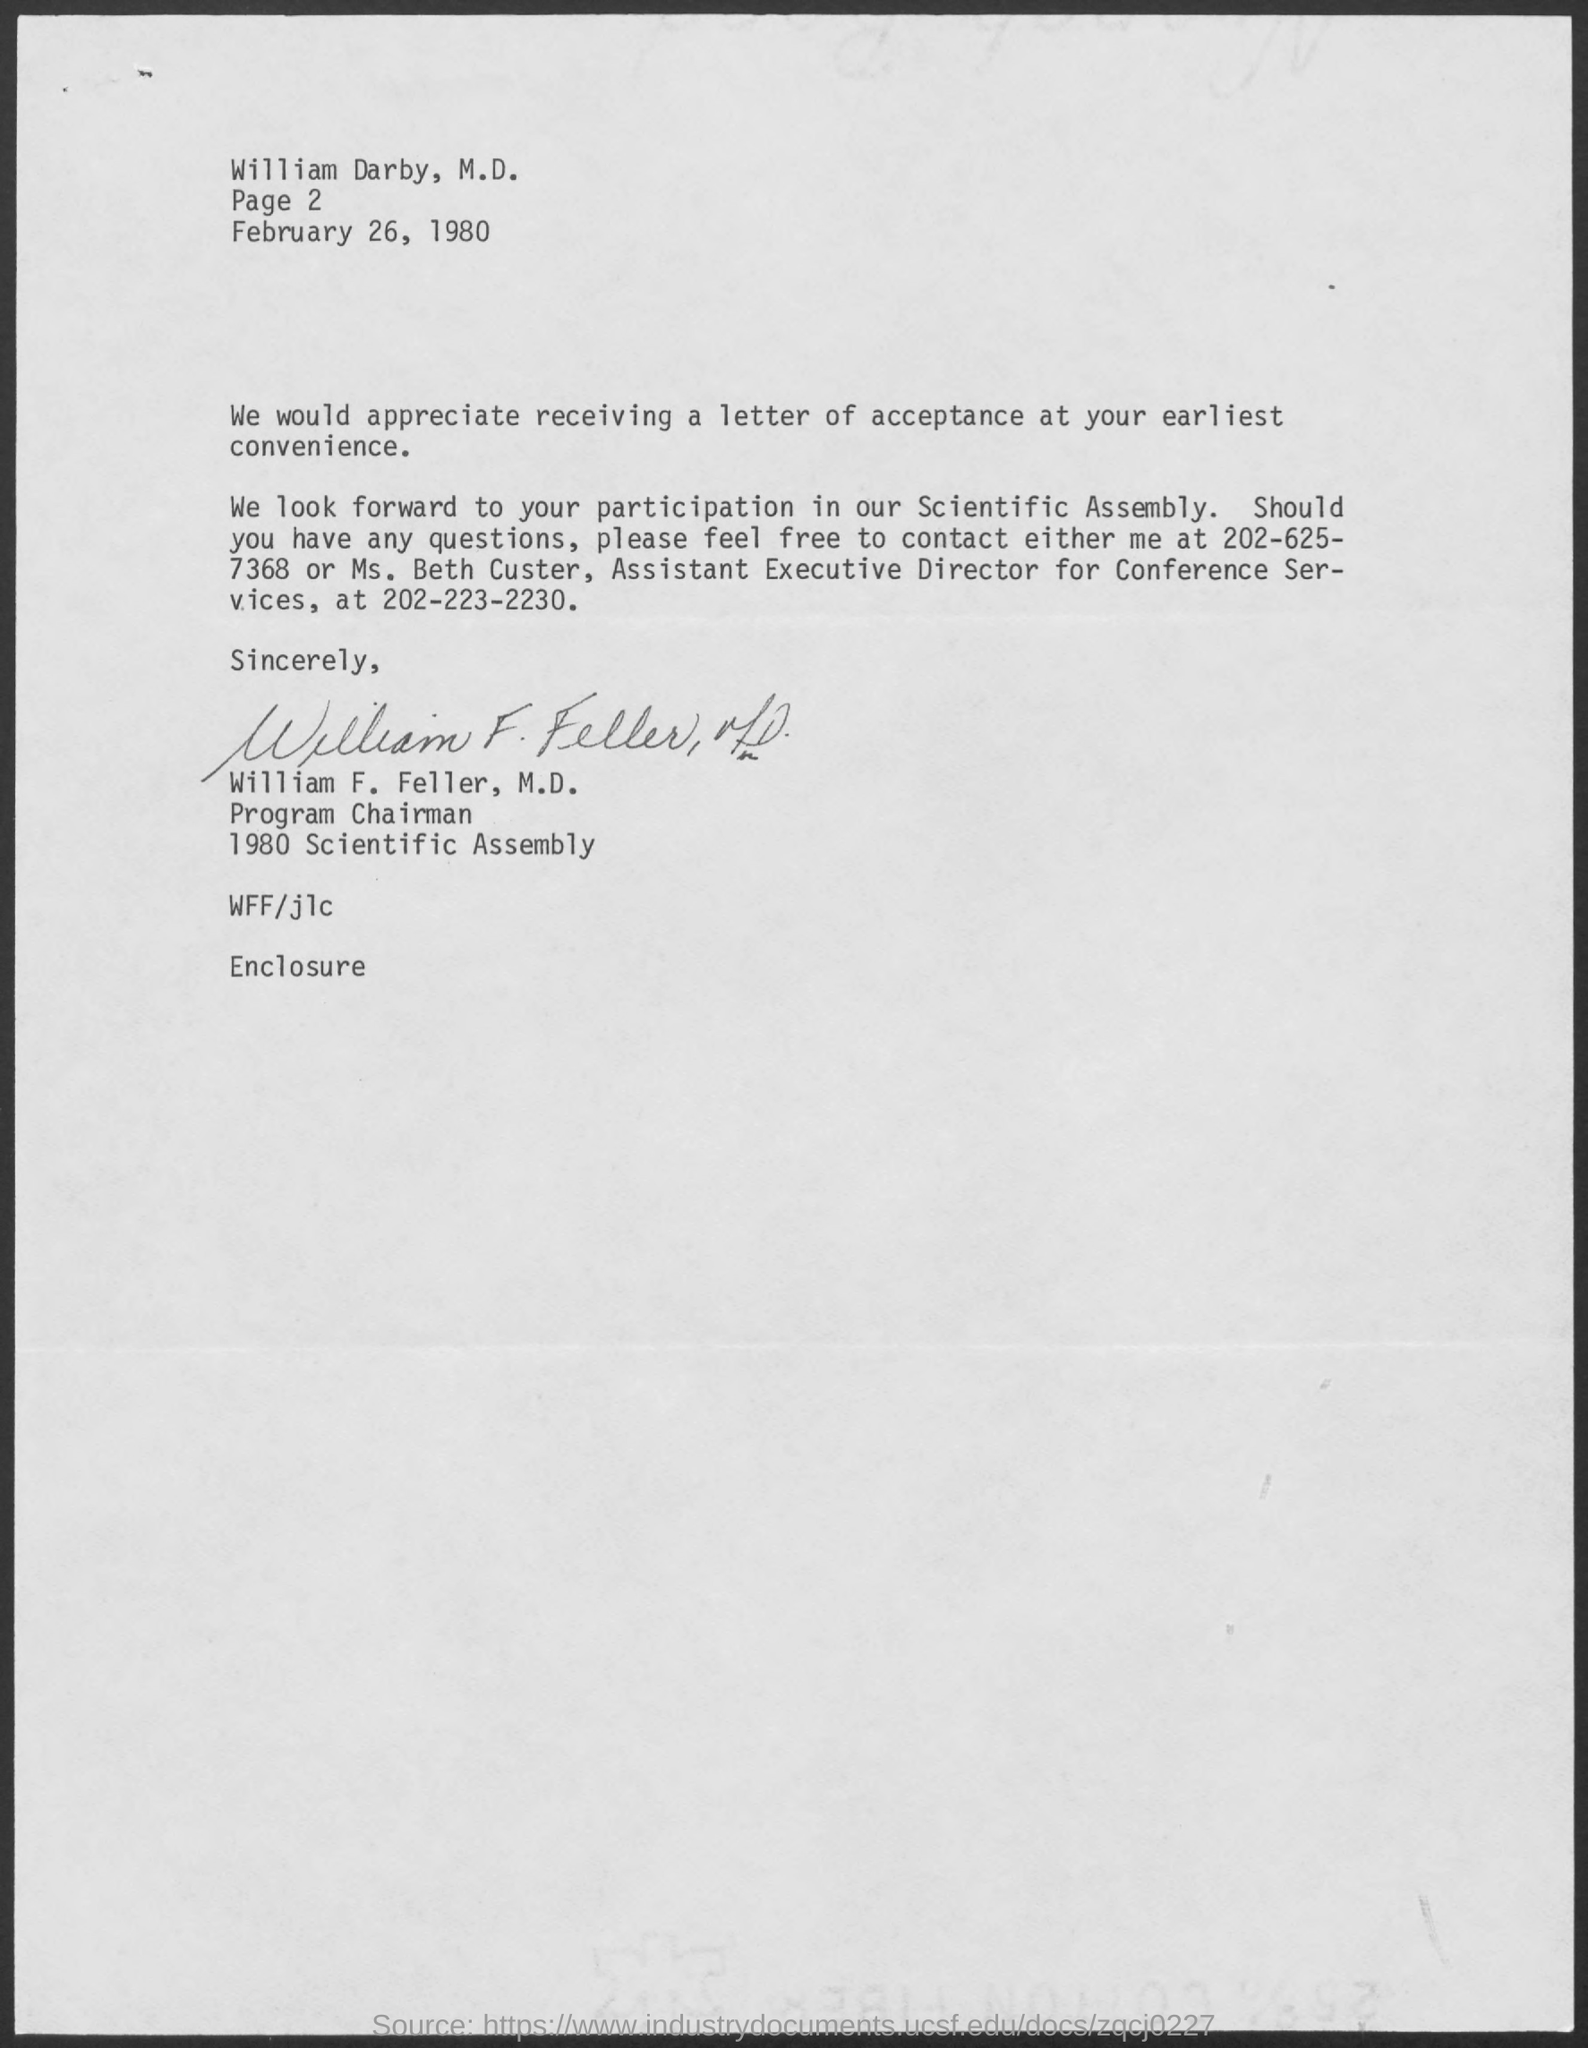Indicate a few pertinent items in this graphic. The contact number of Ms. Beth Custer, as mentioned in the letter, is 202-223-2230. 